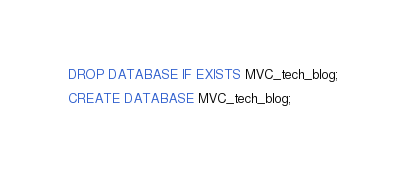<code> <loc_0><loc_0><loc_500><loc_500><_SQL_>DROP DATABASE IF EXISTS MVC_tech_blog;

CREATE DATABASE MVC_tech_blog;</code> 